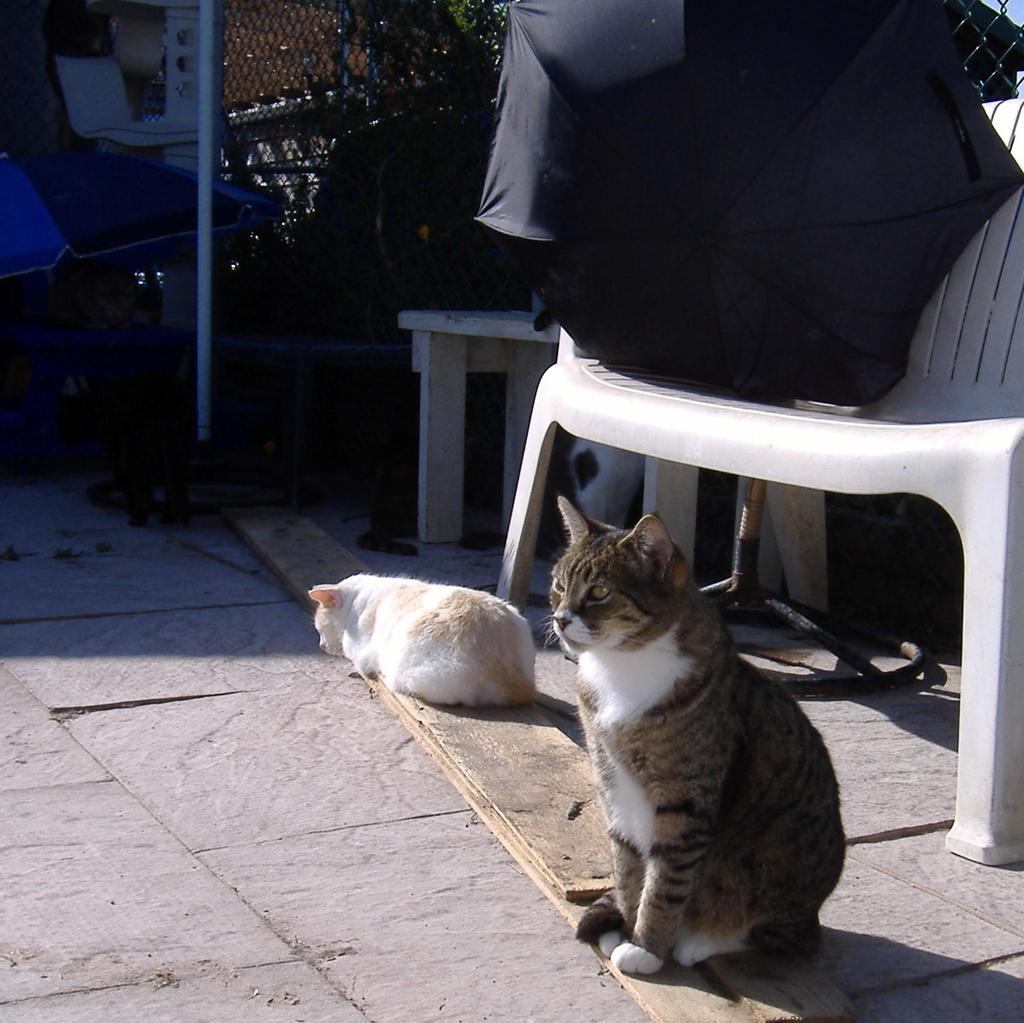What animals are sitting on the wooden plank in the image? There are two cats sitting on a wooden plank in the image. What piece of furniture is present in the image? There is a chair in the image. What is placed on the chair? There is an umbrella on the chair. What can be seen in the background of the image? There is a fence, a pole, and a tree in the background of the image. What type of story is being told by the cats in the image? There is no indication in the image that the cats are telling a story, as they are simply sitting on the wooden plank. Can you see a playground in the image? There is no playground present in the image; it features two cats sitting on a wooden plank, a chair with an umbrella, and various background elements. 